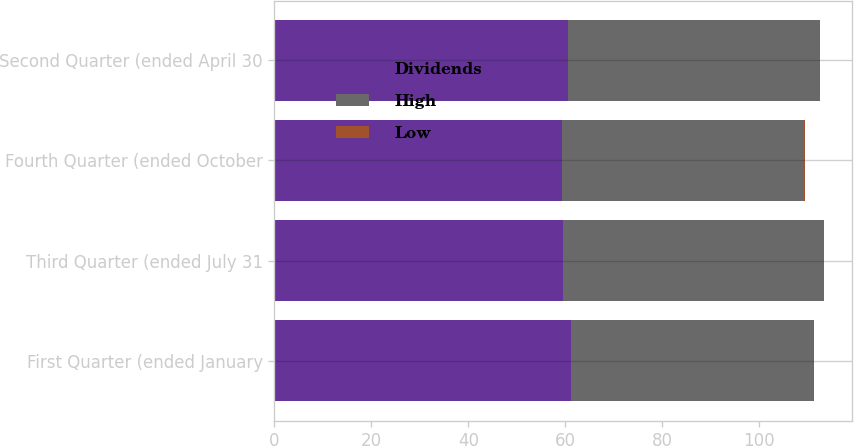Convert chart to OTSL. <chart><loc_0><loc_0><loc_500><loc_500><stacked_bar_chart><ecel><fcel>First Quarter (ended January<fcel>Third Quarter (ended July 31<fcel>Fourth Quarter (ended October<fcel>Second Quarter (ended April 30<nl><fcel>Dividends<fcel>61.22<fcel>59.58<fcel>59.4<fcel>60.46<nl><fcel>High<fcel>49.84<fcel>53.66<fcel>49.8<fcel>51.96<nl><fcel>Low<fcel>0.13<fcel>0.13<fcel>0.13<fcel>0.13<nl></chart> 